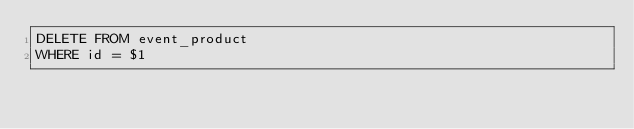Convert code to text. <code><loc_0><loc_0><loc_500><loc_500><_SQL_>DELETE FROM event_product
WHERE id = $1
</code> 